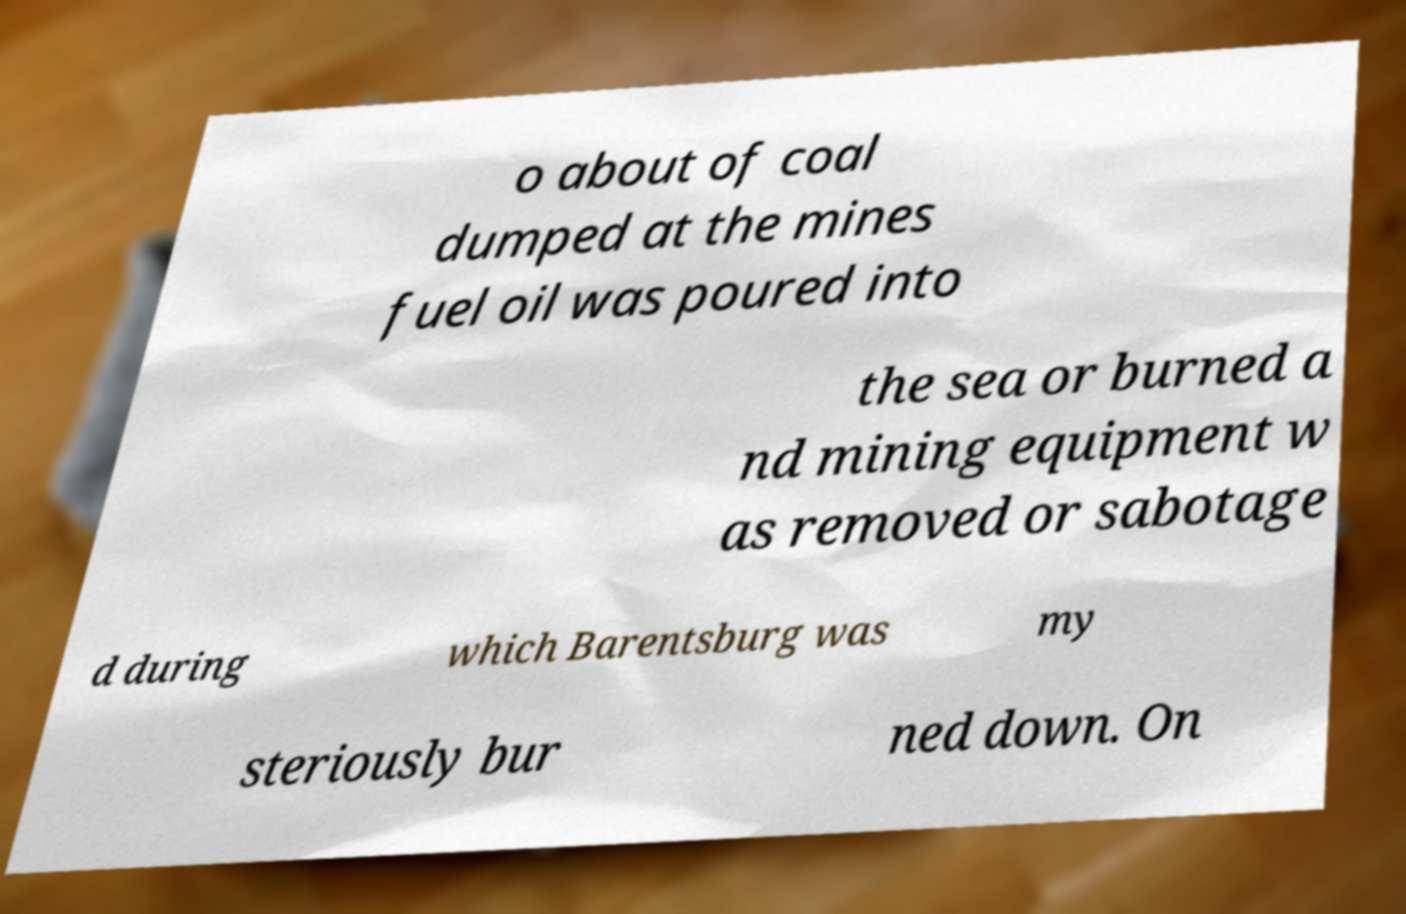Can you accurately transcribe the text from the provided image for me? o about of coal dumped at the mines fuel oil was poured into the sea or burned a nd mining equipment w as removed or sabotage d during which Barentsburg was my steriously bur ned down. On 